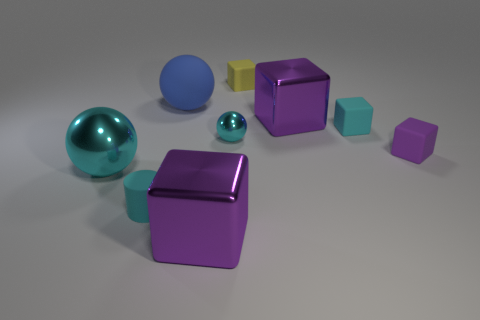How many other objects are there of the same shape as the purple rubber object? In the image, alongside the purple rubber object, which appears to be a cube, there are two other cubes—one teal and one yellow. So there are two objects of the same shape as the purple rubber cube. 